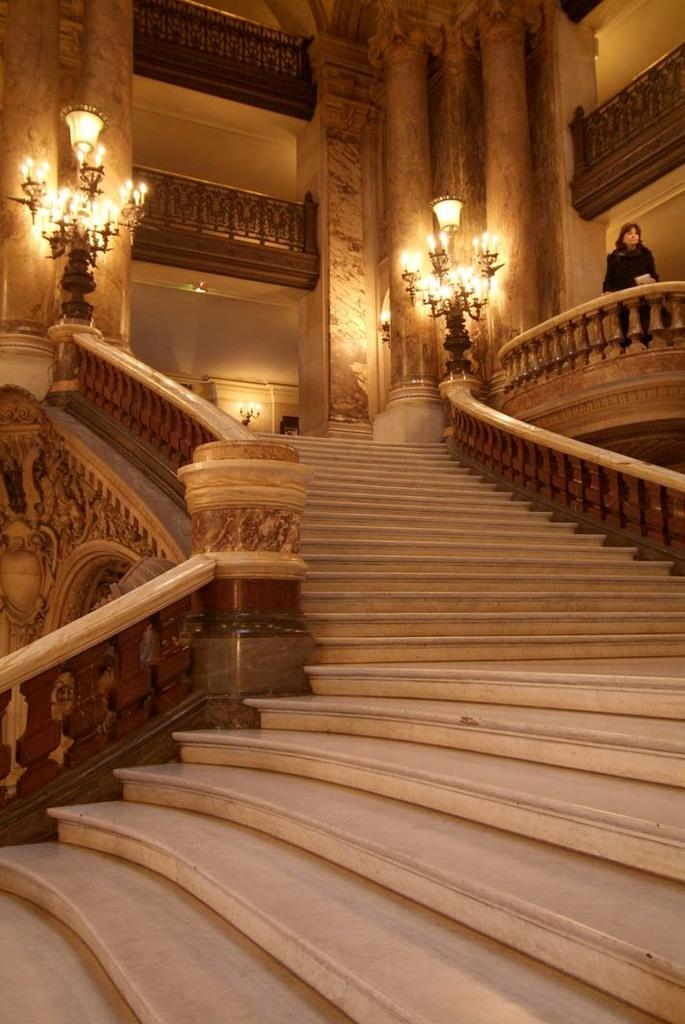What type of architectural feature can be seen in the image? There are steps in the image. What safety feature is present alongside the steps? Railings are present in the image. What can be seen providing illumination in the image? Lights are visible in the image. What type of decorative item is present in the image? Candles are present in the image. Who is present in the image? There is a person standing in the image. What structural elements are present in the image? Pillars are present in the image. What type of stomach ache is the person experiencing in the image? There is no indication of a stomach ache or any medical condition in the image; the person is simply standing. How many pigs are visible in the image? There are no pigs present in the image. What type of sock is the person wearing in the image? There is no sock visible in the image, as the person's feet are not shown. 